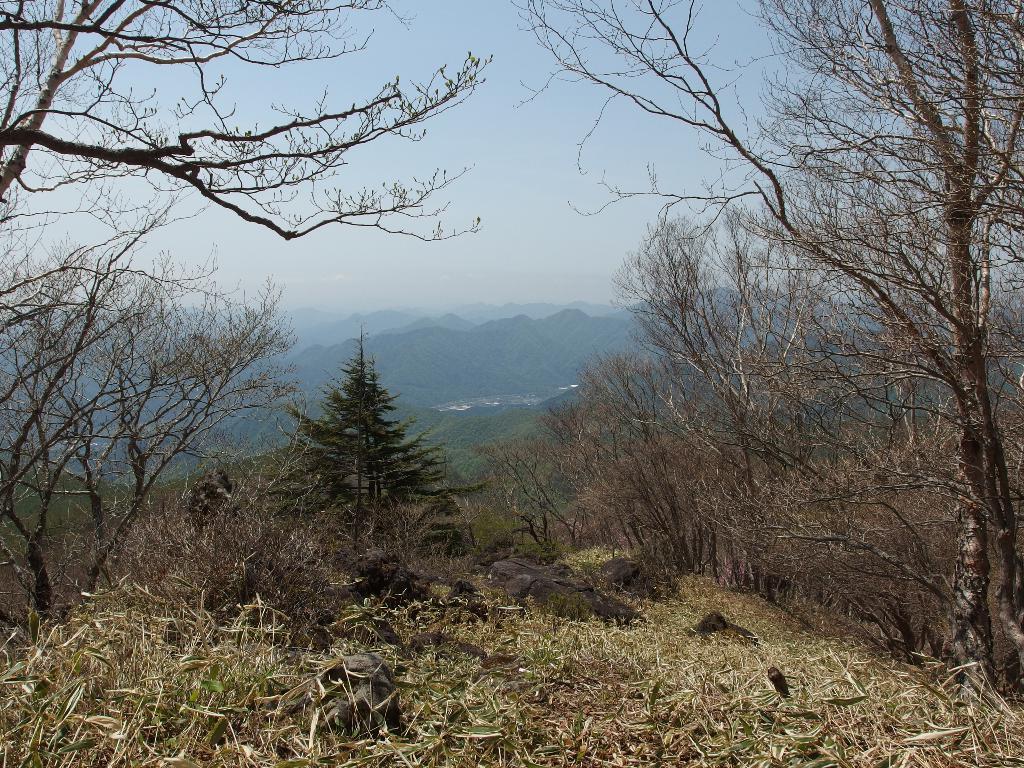Can you describe this image briefly? In the image we can see some trees and hills and clouds and sky. bottom of the image there is grass. 